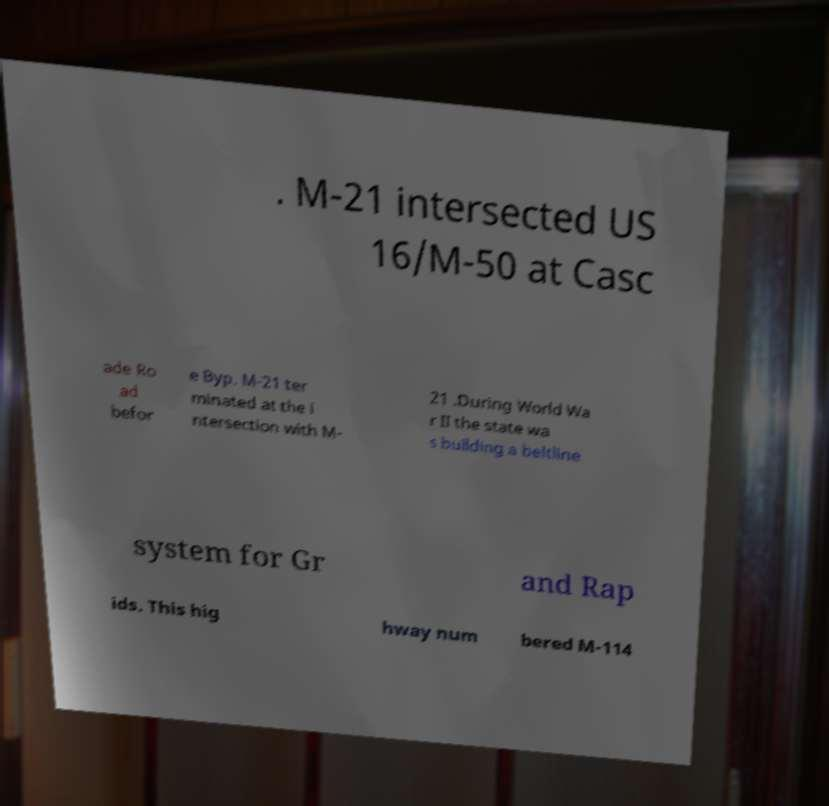Could you assist in decoding the text presented in this image and type it out clearly? . M-21 intersected US 16/M-50 at Casc ade Ro ad befor e Byp. M-21 ter minated at the i ntersection with M- 21 .During World Wa r II the state wa s building a beltline system for Gr and Rap ids. This hig hway num bered M-114 